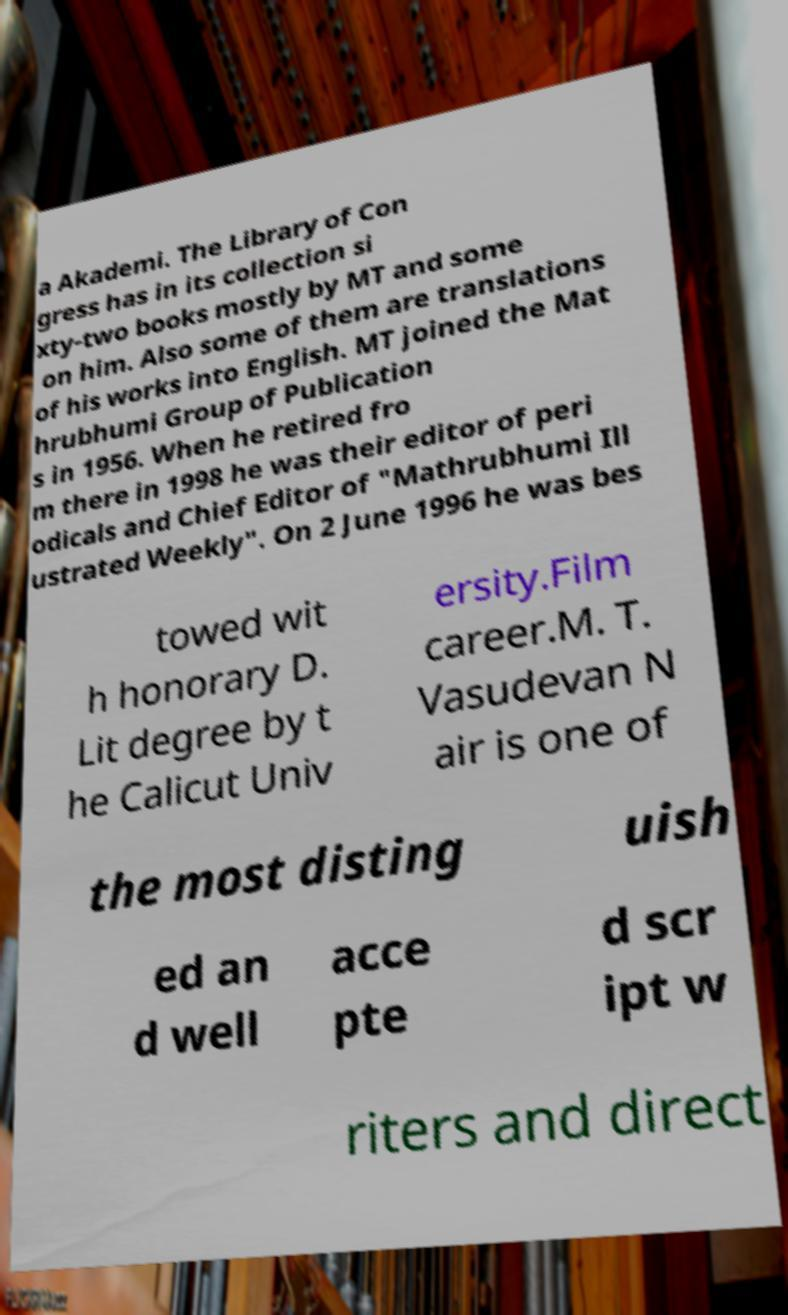For documentation purposes, I need the text within this image transcribed. Could you provide that? a Akademi. The Library of Con gress has in its collection si xty-two books mostly by MT and some on him. Also some of them are translations of his works into English. MT joined the Mat hrubhumi Group of Publication s in 1956. When he retired fro m there in 1998 he was their editor of peri odicals and Chief Editor of "Mathrubhumi Ill ustrated Weekly". On 2 June 1996 he was bes towed wit h honorary D. Lit degree by t he Calicut Univ ersity.Film career.M. T. Vasudevan N air is one of the most disting uish ed an d well acce pte d scr ipt w riters and direct 